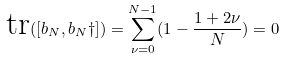<formula> <loc_0><loc_0><loc_500><loc_500>\text {tr} ( [ b _ { N } , b _ { N } \dag ] ) = \sum _ { \nu = 0 } ^ { N - 1 } ( 1 - \frac { 1 + 2 \nu } { N } ) = 0</formula> 